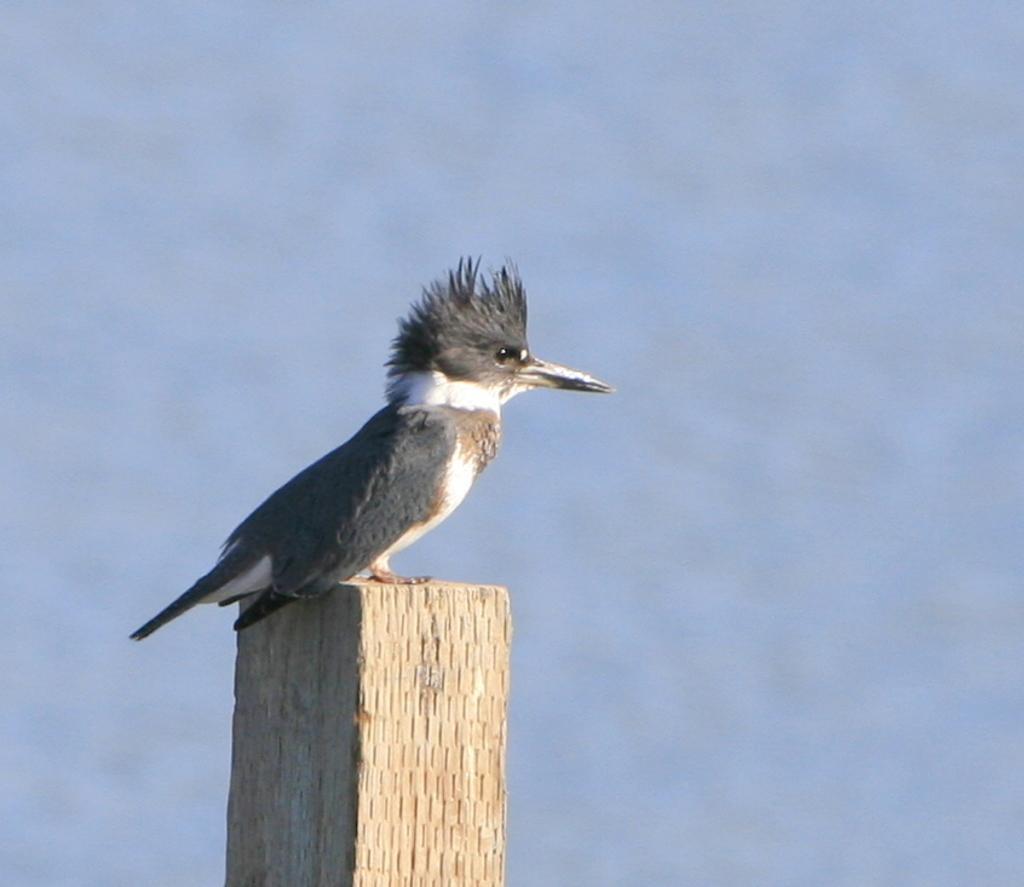How would you summarize this image in a sentence or two? This image consists of a bird. It is in grey color. There is sky in this image. 